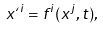<formula> <loc_0><loc_0><loc_500><loc_500>x ` ^ { i } = f ^ { i } ( x ^ { j } , t ) ,</formula> 